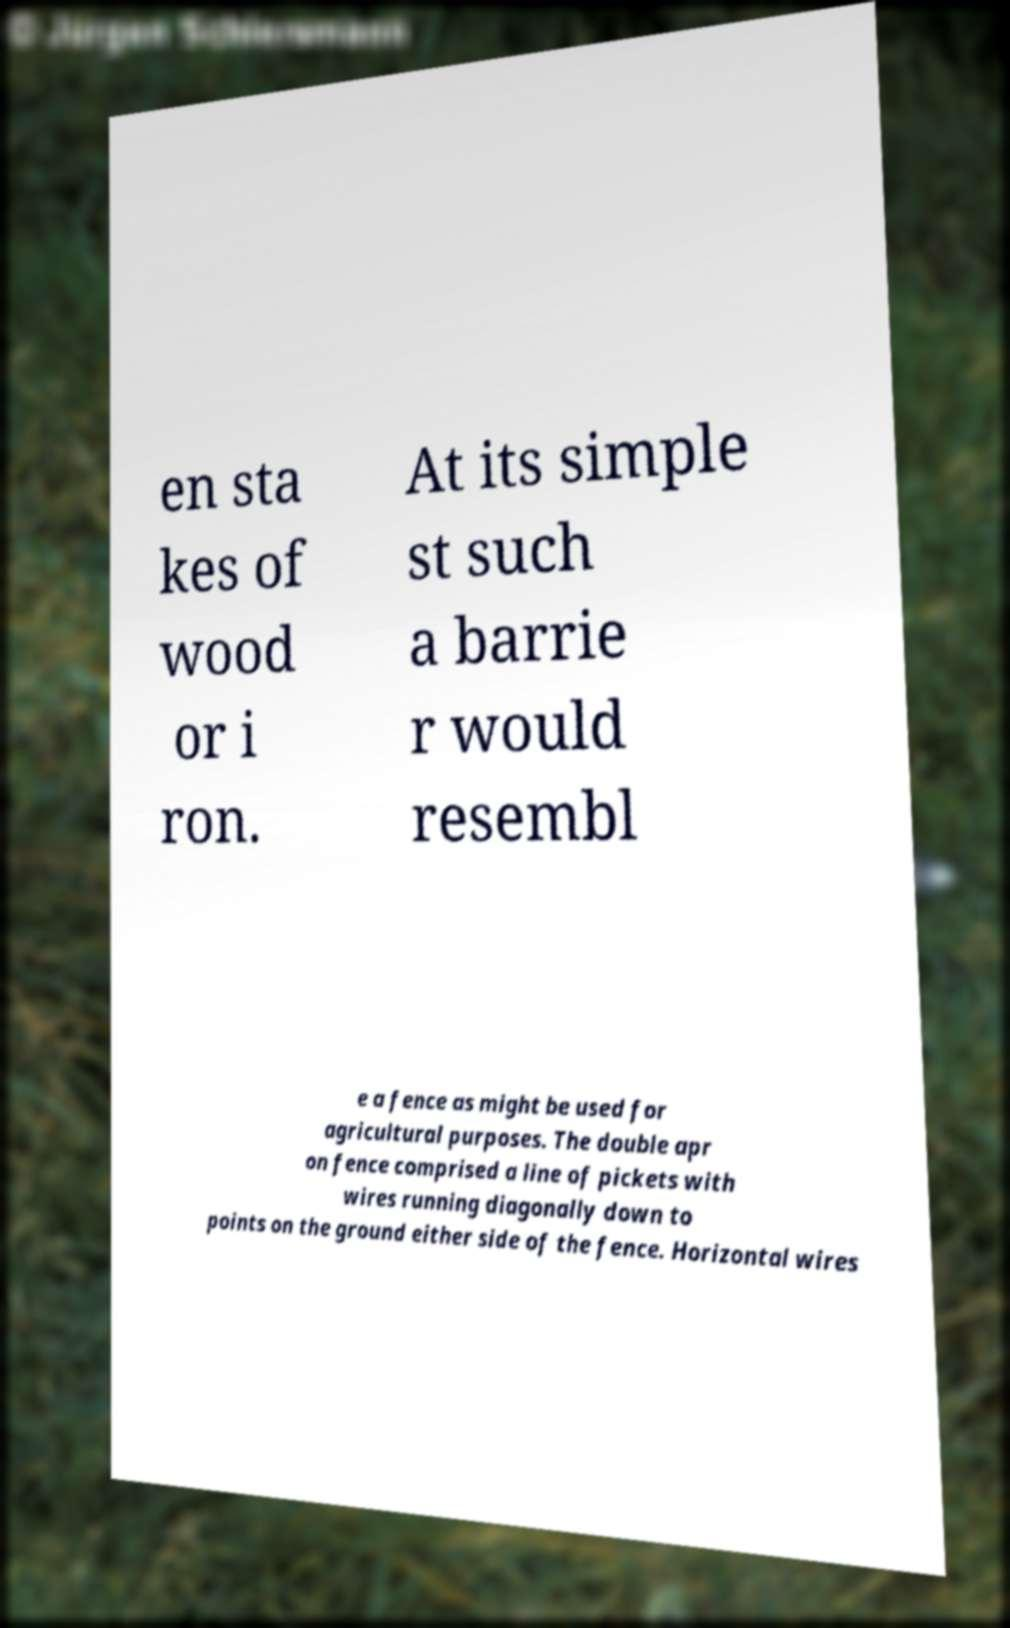Can you accurately transcribe the text from the provided image for me? en sta kes of wood or i ron. At its simple st such a barrie r would resembl e a fence as might be used for agricultural purposes. The double apr on fence comprised a line of pickets with wires running diagonally down to points on the ground either side of the fence. Horizontal wires 